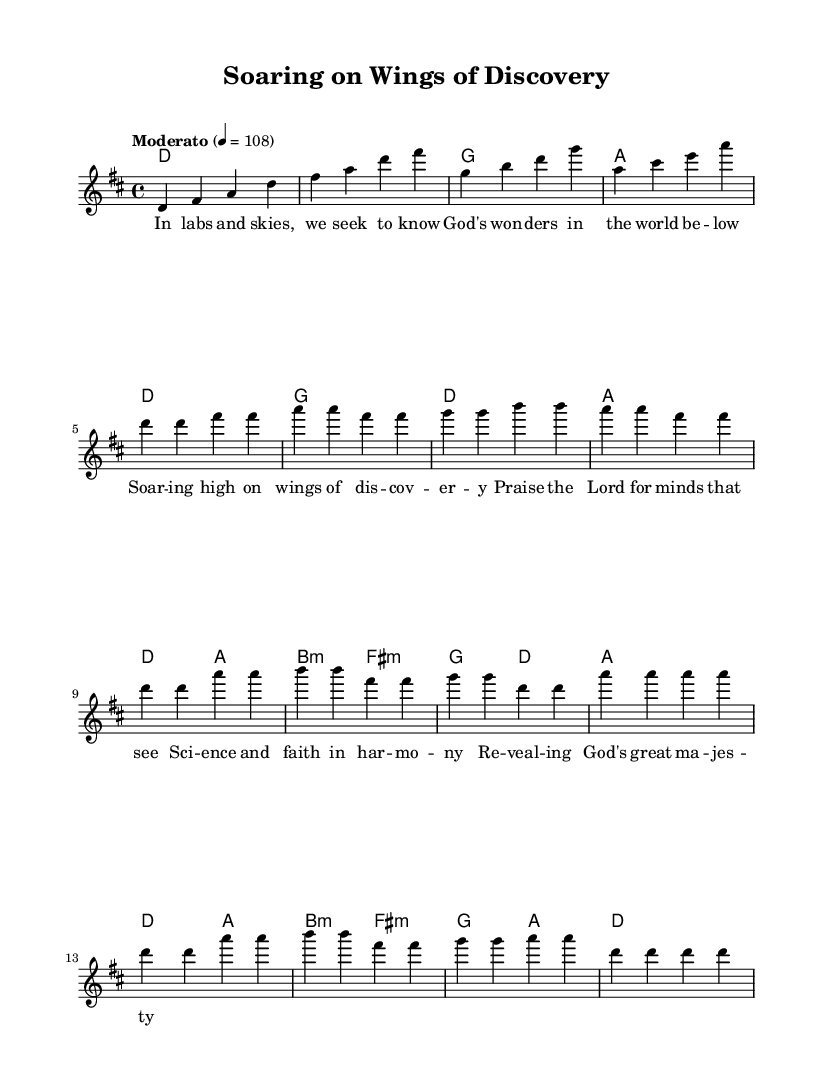What is the key signature of this music? The key signature section specifies D major, which has two sharps (F# and C#). You can determine it by looking for the `\key d \major` command in the global settings of the code, indicating the tonal center of the piece.
Answer: D major What is the time signature of this music? The time signature is indicated by `\time 4/4` in the global settings, meaning there are four beats in each measure, and each beat is a quarter note. This is a common time signature often used in modern music for a steady rhythm.
Answer: 4/4 What is the tempo marking for this music? The tempo is defined as `Moderato` with a tempo marking of 4 = 108, indicating a moderate pace. This is found directly in the global settings of the sheet music, specifying how fast the composition should be played.
Answer: Moderato How many measures are there in the chorus section? The chorus section consists of four measures, as identified by counting the bars in the melody and chord sections specifically labeled as the chorus. Each measure is delineated by vertical lines in the notation.
Answer: Four What theme is portrayed in the lyrics? The lyrics express a theme of praise and awe for scientific discovery and knowledge as part of a religious experience. By examining the verse provided, you can see the wording reflects a celebration of both faith and understanding of God's creation through science.
Answer: Praise for science and faith Which chords are used in the introductory section? The introductory section contains four chords, identified in the `harmonies` section: D, D, G, and A. These chords can be seen aligned with the measures in the score corresponding to the introductory melody part.
Answer: D, D, G, A How does the verse relate to the overall message of the song? The verse establishes a connection between scientific exploration and divine inspiration, conveying how both science and faith can coexist harmoniously. Analyzing the lyrics reveals that they highlight the wonder of creation and understanding the world through a spiritual lens.
Answer: Science and faith in harmony 